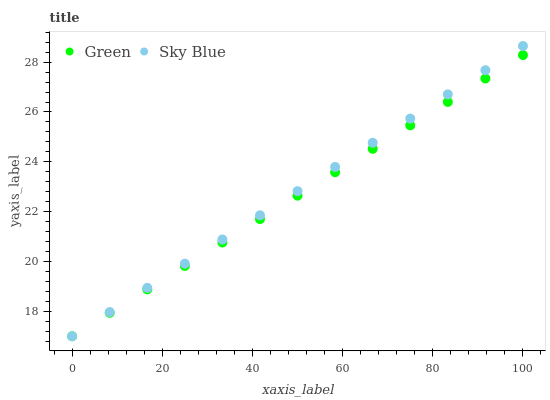Does Green have the minimum area under the curve?
Answer yes or no. Yes. Does Sky Blue have the maximum area under the curve?
Answer yes or no. Yes. Does Green have the maximum area under the curve?
Answer yes or no. No. Is Green the smoothest?
Answer yes or no. Yes. Is Sky Blue the roughest?
Answer yes or no. Yes. Is Green the roughest?
Answer yes or no. No. Does Sky Blue have the lowest value?
Answer yes or no. Yes. Does Sky Blue have the highest value?
Answer yes or no. Yes. Does Green have the highest value?
Answer yes or no. No. Does Green intersect Sky Blue?
Answer yes or no. Yes. Is Green less than Sky Blue?
Answer yes or no. No. Is Green greater than Sky Blue?
Answer yes or no. No. 